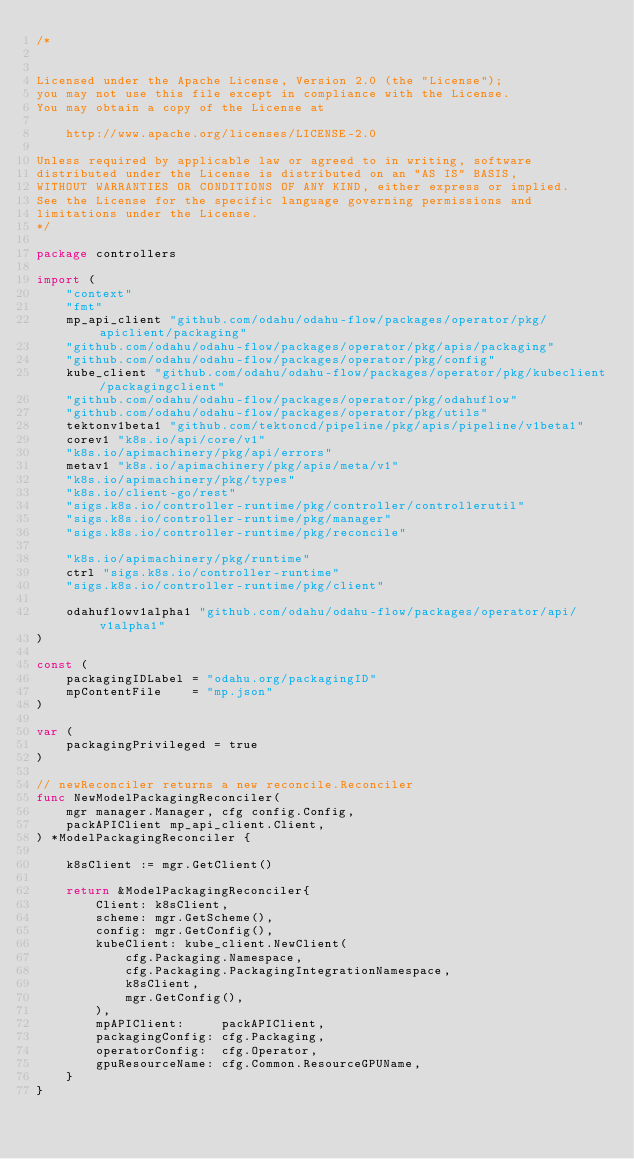<code> <loc_0><loc_0><loc_500><loc_500><_Go_>/*


Licensed under the Apache License, Version 2.0 (the "License");
you may not use this file except in compliance with the License.
You may obtain a copy of the License at

    http://www.apache.org/licenses/LICENSE-2.0

Unless required by applicable law or agreed to in writing, software
distributed under the License is distributed on an "AS IS" BASIS,
WITHOUT WARRANTIES OR CONDITIONS OF ANY KIND, either express or implied.
See the License for the specific language governing permissions and
limitations under the License.
*/

package controllers

import (
	"context"
	"fmt"
	mp_api_client "github.com/odahu/odahu-flow/packages/operator/pkg/apiclient/packaging"
	"github.com/odahu/odahu-flow/packages/operator/pkg/apis/packaging"
	"github.com/odahu/odahu-flow/packages/operator/pkg/config"
	kube_client "github.com/odahu/odahu-flow/packages/operator/pkg/kubeclient/packagingclient"
	"github.com/odahu/odahu-flow/packages/operator/pkg/odahuflow"
	"github.com/odahu/odahu-flow/packages/operator/pkg/utils"
	tektonv1beta1 "github.com/tektoncd/pipeline/pkg/apis/pipeline/v1beta1"
	corev1 "k8s.io/api/core/v1"
	"k8s.io/apimachinery/pkg/api/errors"
	metav1 "k8s.io/apimachinery/pkg/apis/meta/v1"
	"k8s.io/apimachinery/pkg/types"
	"k8s.io/client-go/rest"
	"sigs.k8s.io/controller-runtime/pkg/controller/controllerutil"
	"sigs.k8s.io/controller-runtime/pkg/manager"
	"sigs.k8s.io/controller-runtime/pkg/reconcile"

	"k8s.io/apimachinery/pkg/runtime"
	ctrl "sigs.k8s.io/controller-runtime"
	"sigs.k8s.io/controller-runtime/pkg/client"

	odahuflowv1alpha1 "github.com/odahu/odahu-flow/packages/operator/api/v1alpha1"
)

const (
	packagingIDLabel = "odahu.org/packagingID"
	mpContentFile    = "mp.json"
)

var (
	packagingPrivileged = true
)

// newReconciler returns a new reconcile.Reconciler
func NewModelPackagingReconciler(
	mgr manager.Manager, cfg config.Config,
	packAPIClient mp_api_client.Client,
) *ModelPackagingReconciler {

	k8sClient := mgr.GetClient()

	return &ModelPackagingReconciler{
		Client: k8sClient,
		scheme: mgr.GetScheme(),
		config: mgr.GetConfig(),
		kubeClient: kube_client.NewClient(
			cfg.Packaging.Namespace,
			cfg.Packaging.PackagingIntegrationNamespace,
			k8sClient,
			mgr.GetConfig(),
		),
		mpAPIClient:     packAPIClient,
		packagingConfig: cfg.Packaging,
		operatorConfig:  cfg.Operator,
		gpuResourceName: cfg.Common.ResourceGPUName,
	}
}
</code> 